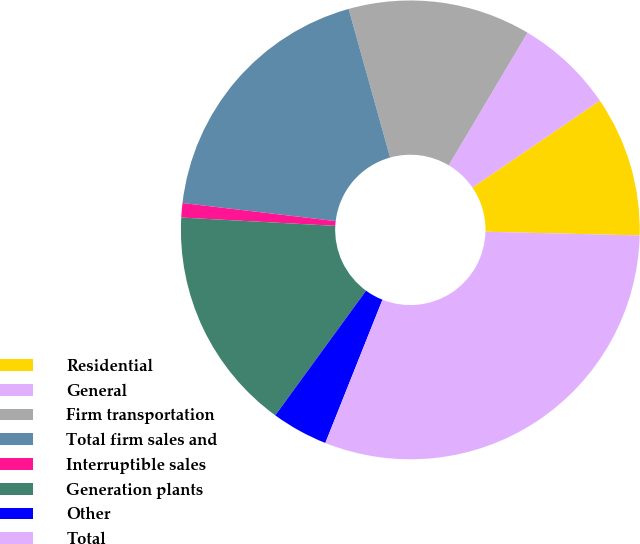<chart> <loc_0><loc_0><loc_500><loc_500><pie_chart><fcel>Residential<fcel>General<fcel>Firm transportation<fcel>Total firm sales and<fcel>Interruptible sales<fcel>Generation plants<fcel>Other<fcel>Total<nl><fcel>9.91%<fcel>6.94%<fcel>12.87%<fcel>18.8%<fcel>1.01%<fcel>15.84%<fcel>3.98%<fcel>30.66%<nl></chart> 